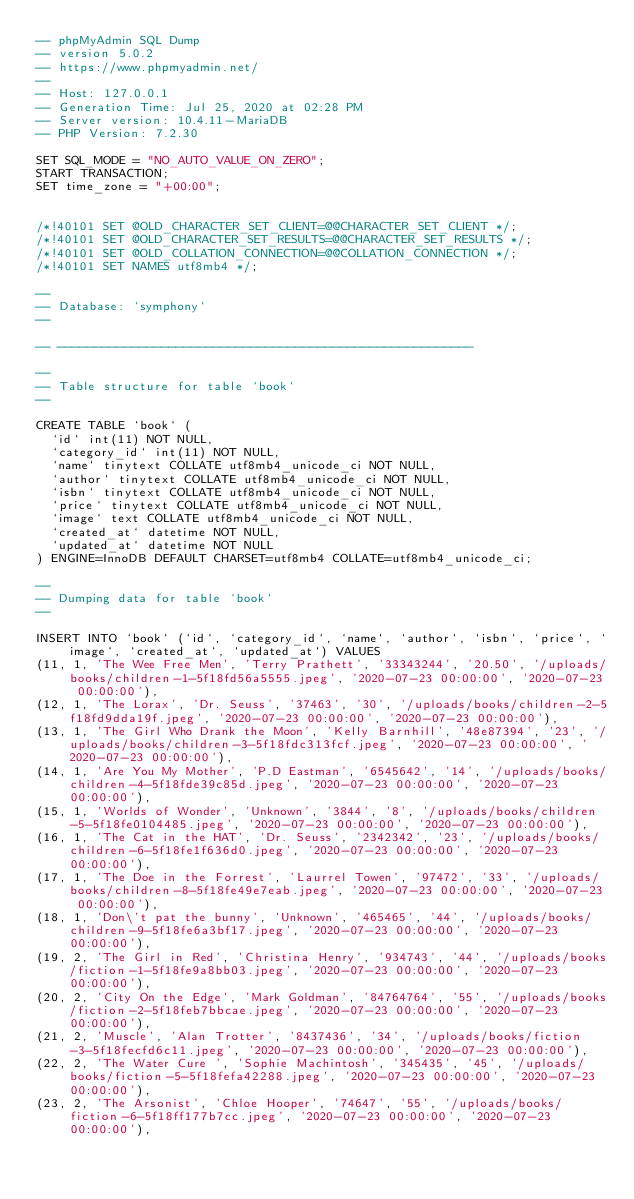<code> <loc_0><loc_0><loc_500><loc_500><_SQL_>-- phpMyAdmin SQL Dump
-- version 5.0.2
-- https://www.phpmyadmin.net/
--
-- Host: 127.0.0.1
-- Generation Time: Jul 25, 2020 at 02:28 PM
-- Server version: 10.4.11-MariaDB
-- PHP Version: 7.2.30

SET SQL_MODE = "NO_AUTO_VALUE_ON_ZERO";
START TRANSACTION;
SET time_zone = "+00:00";


/*!40101 SET @OLD_CHARACTER_SET_CLIENT=@@CHARACTER_SET_CLIENT */;
/*!40101 SET @OLD_CHARACTER_SET_RESULTS=@@CHARACTER_SET_RESULTS */;
/*!40101 SET @OLD_COLLATION_CONNECTION=@@COLLATION_CONNECTION */;
/*!40101 SET NAMES utf8mb4 */;

--
-- Database: `symphony`
--

-- --------------------------------------------------------

--
-- Table structure for table `book`
--

CREATE TABLE `book` (
  `id` int(11) NOT NULL,
  `category_id` int(11) NOT NULL,
  `name` tinytext COLLATE utf8mb4_unicode_ci NOT NULL,
  `author` tinytext COLLATE utf8mb4_unicode_ci NOT NULL,
  `isbn` tinytext COLLATE utf8mb4_unicode_ci NOT NULL,
  `price` tinytext COLLATE utf8mb4_unicode_ci NOT NULL,
  `image` text COLLATE utf8mb4_unicode_ci NOT NULL,
  `created_at` datetime NOT NULL,
  `updated_at` datetime NOT NULL
) ENGINE=InnoDB DEFAULT CHARSET=utf8mb4 COLLATE=utf8mb4_unicode_ci;

--
-- Dumping data for table `book`
--

INSERT INTO `book` (`id`, `category_id`, `name`, `author`, `isbn`, `price`, `image`, `created_at`, `updated_at`) VALUES
(11, 1, 'The Wee Free Men', 'Terry Prathett', '33343244', '20.50', '/uploads/books/children-1-5f18fd56a5555.jpeg', '2020-07-23 00:00:00', '2020-07-23 00:00:00'),
(12, 1, 'The Lorax', 'Dr. Seuss', '37463', '30', '/uploads/books/children-2-5f18fd9dda19f.jpeg', '2020-07-23 00:00:00', '2020-07-23 00:00:00'),
(13, 1, 'The Girl Who Drank the Moon', 'Kelly Barnhill', '48e87394', '23', '/uploads/books/children-3-5f18fdc313fcf.jpeg', '2020-07-23 00:00:00', '2020-07-23 00:00:00'),
(14, 1, 'Are You My Mother', 'P.D Eastman', '6545642', '14', '/uploads/books/children-4-5f18fde39c85d.jpeg', '2020-07-23 00:00:00', '2020-07-23 00:00:00'),
(15, 1, 'Worlds of Wonder', 'Unknown', '3844', '8', '/uploads/books/children-5-5f18fe0104485.jpeg', '2020-07-23 00:00:00', '2020-07-23 00:00:00'),
(16, 1, 'The Cat in the HAT', 'Dr. Seuss', '2342342', '23', '/uploads/books/children-6-5f18fe1f636d0.jpeg', '2020-07-23 00:00:00', '2020-07-23 00:00:00'),
(17, 1, 'The Doe in the Forrest', 'Laurrel Towen', '97472', '33', '/uploads/books/children-8-5f18fe49e7eab.jpeg', '2020-07-23 00:00:00', '2020-07-23 00:00:00'),
(18, 1, 'Don\'t pat the bunny', 'Unknown', '465465', '44', '/uploads/books/children-9-5f18fe6a3bf17.jpeg', '2020-07-23 00:00:00', '2020-07-23 00:00:00'),
(19, 2, 'The Girl in Red', 'Christina Henry', '934743', '44', '/uploads/books/fiction-1-5f18fe9a8bb03.jpeg', '2020-07-23 00:00:00', '2020-07-23 00:00:00'),
(20, 2, 'City On the Edge', 'Mark Goldman', '84764764', '55', '/uploads/books/fiction-2-5f18feb7bbcae.jpeg', '2020-07-23 00:00:00', '2020-07-23 00:00:00'),
(21, 2, 'Muscle', 'Alan Trotter', '8437436', '34', '/uploads/books/fiction-3-5f18fecfd6c11.jpeg', '2020-07-23 00:00:00', '2020-07-23 00:00:00'),
(22, 2, 'The Water Cure ', 'Sophie Machintosh', '345435', '45', '/uploads/books/fiction-5-5f18fefa42288.jpeg', '2020-07-23 00:00:00', '2020-07-23 00:00:00'),
(23, 2, 'The Arsonist', 'Chloe Hooper', '74647', '55', '/uploads/books/fiction-6-5f18ff177b7cc.jpeg', '2020-07-23 00:00:00', '2020-07-23 00:00:00'),</code> 